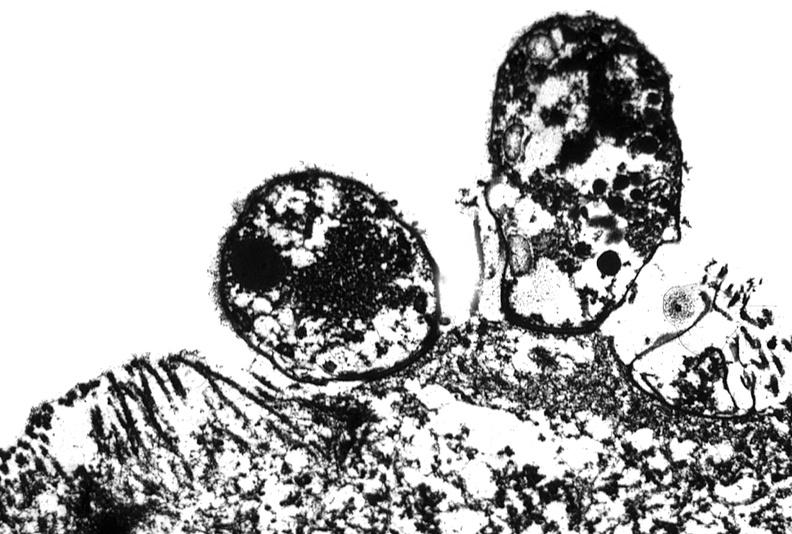does previous slide from this case show colon biopsy, cryptosporidia?
Answer the question using a single word or phrase. No 